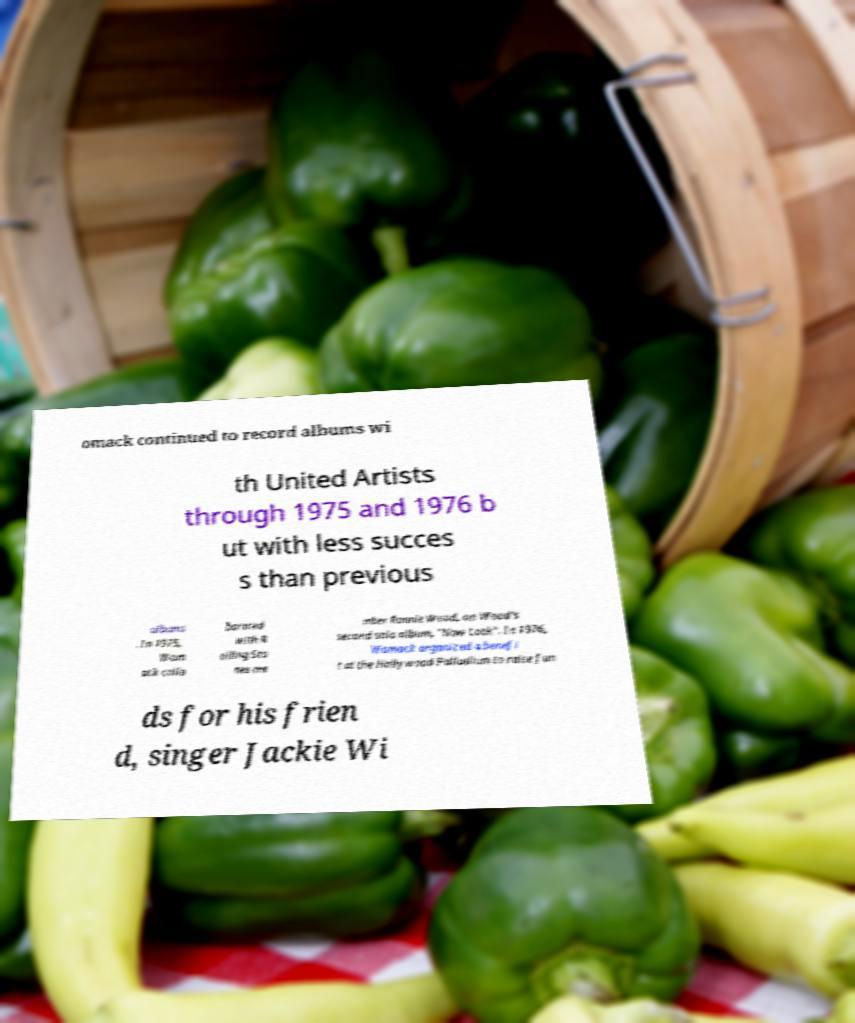Could you assist in decoding the text presented in this image and type it out clearly? omack continued to record albums wi th United Artists through 1975 and 1976 b ut with less succes s than previous albums . In 1975, Wom ack colla borated with R olling Sto nes me mber Ronnie Wood, on Wood's second solo album, "Now Look". In 1976, Womack organized a benefi t at the Hollywood Palladium to raise fun ds for his frien d, singer Jackie Wi 